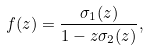<formula> <loc_0><loc_0><loc_500><loc_500>f ( z ) = \frac { \sigma _ { 1 } ( z ) } { 1 - z \sigma _ { 2 } ( z ) } ,</formula> 